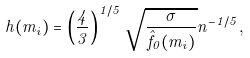Convert formula to latex. <formula><loc_0><loc_0><loc_500><loc_500>h ( m _ { i } ) = \left ( \frac { 4 } { 3 } \right ) ^ { 1 / 5 } \sqrt { \frac { \sigma } { \hat { f } _ { 0 } ( m _ { i } ) } } n ^ { - 1 / 5 } ,</formula> 